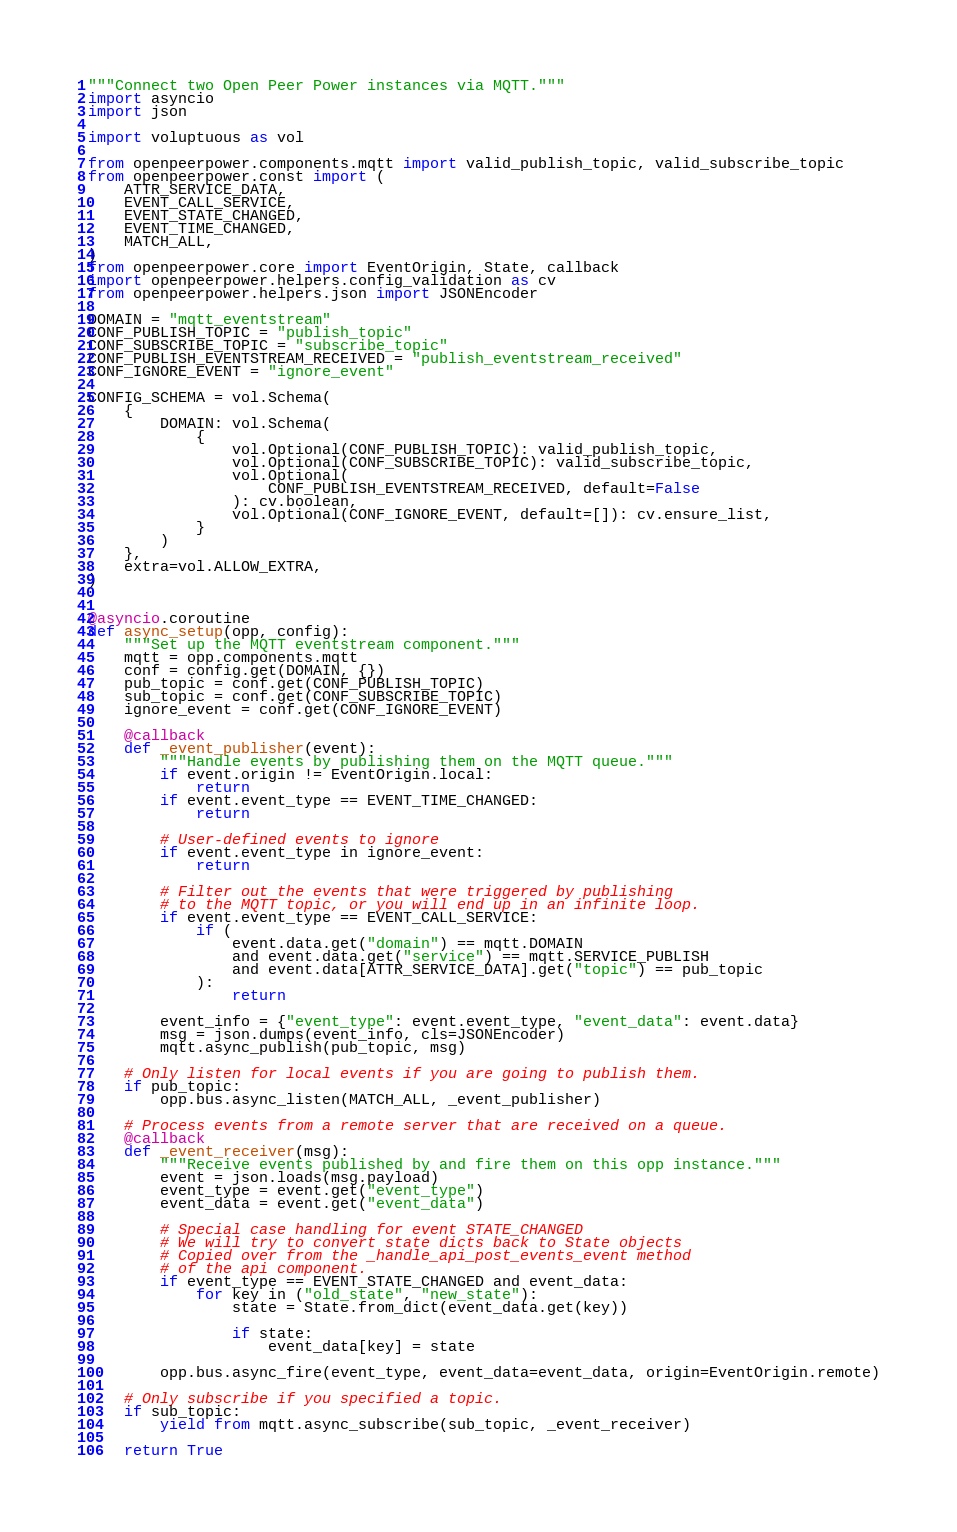<code> <loc_0><loc_0><loc_500><loc_500><_Python_>"""Connect two Open Peer Power instances via MQTT."""
import asyncio
import json

import voluptuous as vol

from openpeerpower.components.mqtt import valid_publish_topic, valid_subscribe_topic
from openpeerpower.const import (
    ATTR_SERVICE_DATA,
    EVENT_CALL_SERVICE,
    EVENT_STATE_CHANGED,
    EVENT_TIME_CHANGED,
    MATCH_ALL,
)
from openpeerpower.core import EventOrigin, State, callback
import openpeerpower.helpers.config_validation as cv
from openpeerpower.helpers.json import JSONEncoder

DOMAIN = "mqtt_eventstream"
CONF_PUBLISH_TOPIC = "publish_topic"
CONF_SUBSCRIBE_TOPIC = "subscribe_topic"
CONF_PUBLISH_EVENTSTREAM_RECEIVED = "publish_eventstream_received"
CONF_IGNORE_EVENT = "ignore_event"

CONFIG_SCHEMA = vol.Schema(
    {
        DOMAIN: vol.Schema(
            {
                vol.Optional(CONF_PUBLISH_TOPIC): valid_publish_topic,
                vol.Optional(CONF_SUBSCRIBE_TOPIC): valid_subscribe_topic,
                vol.Optional(
                    CONF_PUBLISH_EVENTSTREAM_RECEIVED, default=False
                ): cv.boolean,
                vol.Optional(CONF_IGNORE_EVENT, default=[]): cv.ensure_list,
            }
        )
    },
    extra=vol.ALLOW_EXTRA,
)


@asyncio.coroutine
def async_setup(opp, config):
    """Set up the MQTT eventstream component."""
    mqtt = opp.components.mqtt
    conf = config.get(DOMAIN, {})
    pub_topic = conf.get(CONF_PUBLISH_TOPIC)
    sub_topic = conf.get(CONF_SUBSCRIBE_TOPIC)
    ignore_event = conf.get(CONF_IGNORE_EVENT)

    @callback
    def _event_publisher(event):
        """Handle events by publishing them on the MQTT queue."""
        if event.origin != EventOrigin.local:
            return
        if event.event_type == EVENT_TIME_CHANGED:
            return

        # User-defined events to ignore
        if event.event_type in ignore_event:
            return

        # Filter out the events that were triggered by publishing
        # to the MQTT topic, or you will end up in an infinite loop.
        if event.event_type == EVENT_CALL_SERVICE:
            if (
                event.data.get("domain") == mqtt.DOMAIN
                and event.data.get("service") == mqtt.SERVICE_PUBLISH
                and event.data[ATTR_SERVICE_DATA].get("topic") == pub_topic
            ):
                return

        event_info = {"event_type": event.event_type, "event_data": event.data}
        msg = json.dumps(event_info, cls=JSONEncoder)
        mqtt.async_publish(pub_topic, msg)

    # Only listen for local events if you are going to publish them.
    if pub_topic:
        opp.bus.async_listen(MATCH_ALL, _event_publisher)

    # Process events from a remote server that are received on a queue.
    @callback
    def _event_receiver(msg):
        """Receive events published by and fire them on this opp instance."""
        event = json.loads(msg.payload)
        event_type = event.get("event_type")
        event_data = event.get("event_data")

        # Special case handling for event STATE_CHANGED
        # We will try to convert state dicts back to State objects
        # Copied over from the _handle_api_post_events_event method
        # of the api component.
        if event_type == EVENT_STATE_CHANGED and event_data:
            for key in ("old_state", "new_state"):
                state = State.from_dict(event_data.get(key))

                if state:
                    event_data[key] = state

        opp.bus.async_fire(event_type, event_data=event_data, origin=EventOrigin.remote)

    # Only subscribe if you specified a topic.
    if sub_topic:
        yield from mqtt.async_subscribe(sub_topic, _event_receiver)

    return True
</code> 